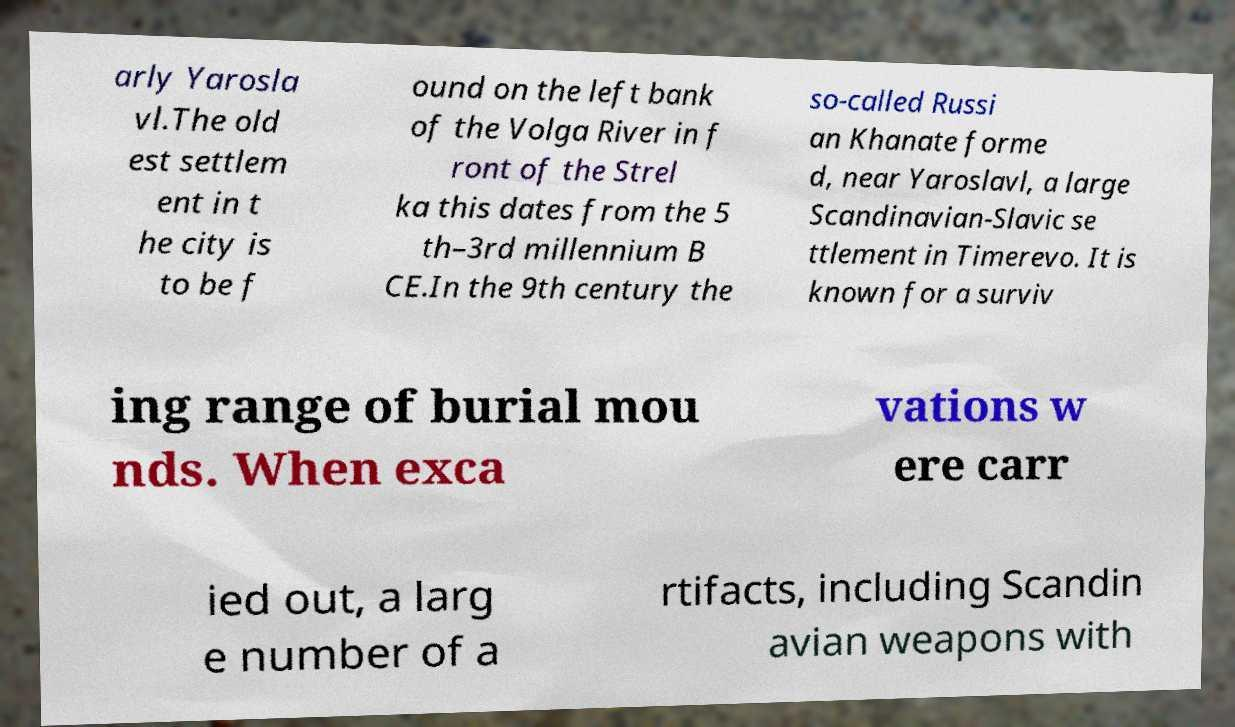I need the written content from this picture converted into text. Can you do that? arly Yarosla vl.The old est settlem ent in t he city is to be f ound on the left bank of the Volga River in f ront of the Strel ka this dates from the 5 th–3rd millennium B CE.In the 9th century the so-called Russi an Khanate forme d, near Yaroslavl, a large Scandinavian-Slavic se ttlement in Timerevo. It is known for a surviv ing range of burial mou nds. When exca vations w ere carr ied out, a larg e number of a rtifacts, including Scandin avian weapons with 